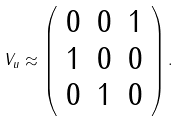Convert formula to latex. <formula><loc_0><loc_0><loc_500><loc_500>V _ { u } \approx \left ( \begin{array} { c c c } 0 & 0 & 1 \\ 1 & 0 & 0 \\ 0 & 1 & 0 \end{array} \right ) .</formula> 